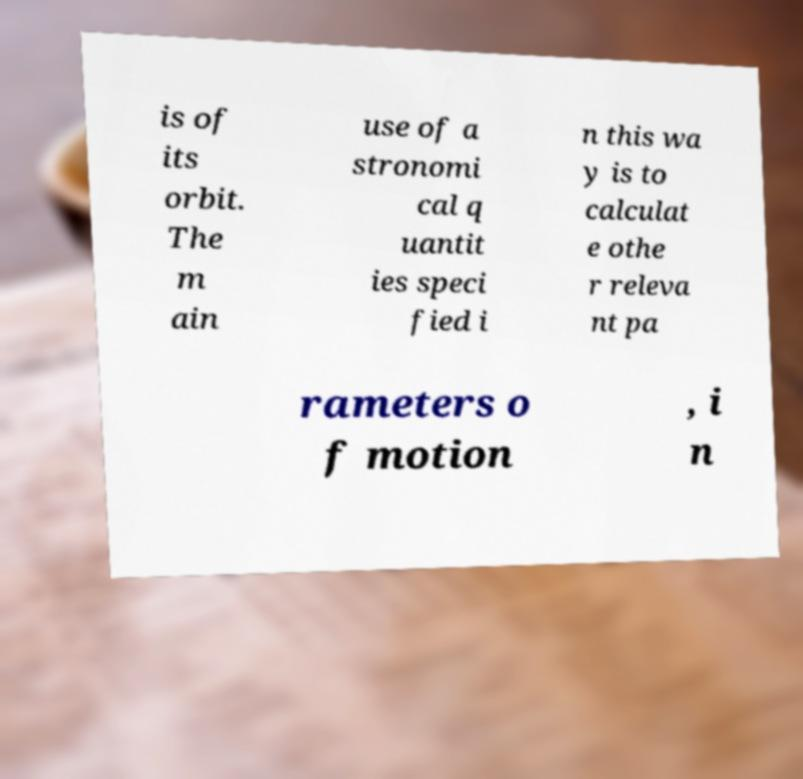Could you assist in decoding the text presented in this image and type it out clearly? is of its orbit. The m ain use of a stronomi cal q uantit ies speci fied i n this wa y is to calculat e othe r releva nt pa rameters o f motion , i n 